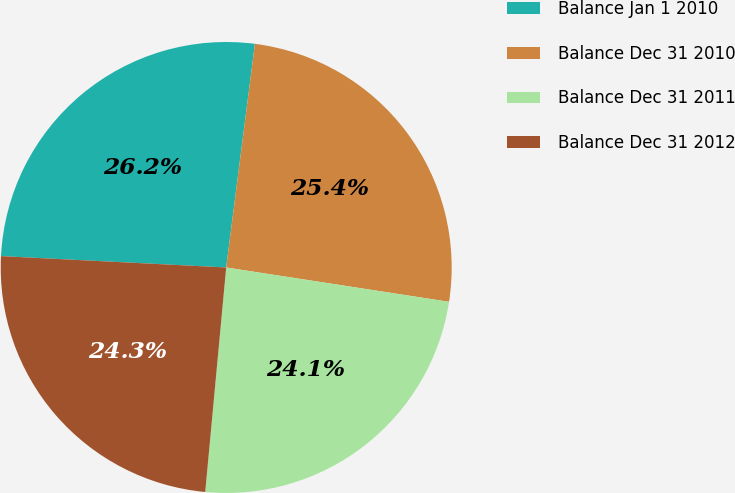Convert chart to OTSL. <chart><loc_0><loc_0><loc_500><loc_500><pie_chart><fcel>Balance Jan 1 2010<fcel>Balance Dec 31 2010<fcel>Balance Dec 31 2011<fcel>Balance Dec 31 2012<nl><fcel>26.23%<fcel>25.4%<fcel>24.05%<fcel>24.32%<nl></chart> 